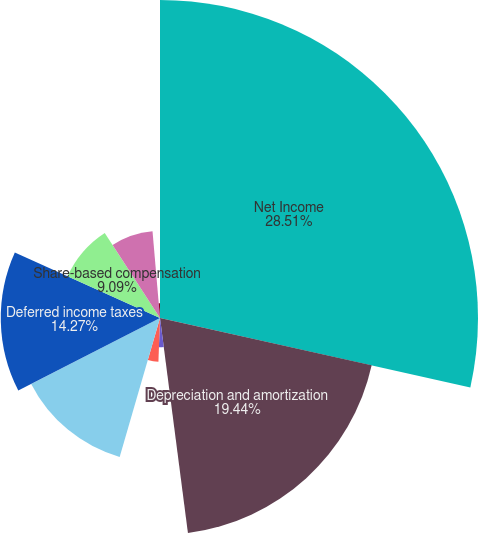Convert chart. <chart><loc_0><loc_0><loc_500><loc_500><pie_chart><fcel>Net Income<fcel>Depreciation and amortization<fcel>Closures and impairment<fcel>Refranchising (gain) loss<fcel>Contributions to defined<fcel>Deferred income taxes<fcel>Share-based compensation<fcel>Changes in accounts and notes<fcel>Changes in inventories<fcel>Changes in prepaid expenses<nl><fcel>28.5%<fcel>19.44%<fcel>2.63%<fcel>3.92%<fcel>12.97%<fcel>14.27%<fcel>9.09%<fcel>7.8%<fcel>0.04%<fcel>1.33%<nl></chart> 